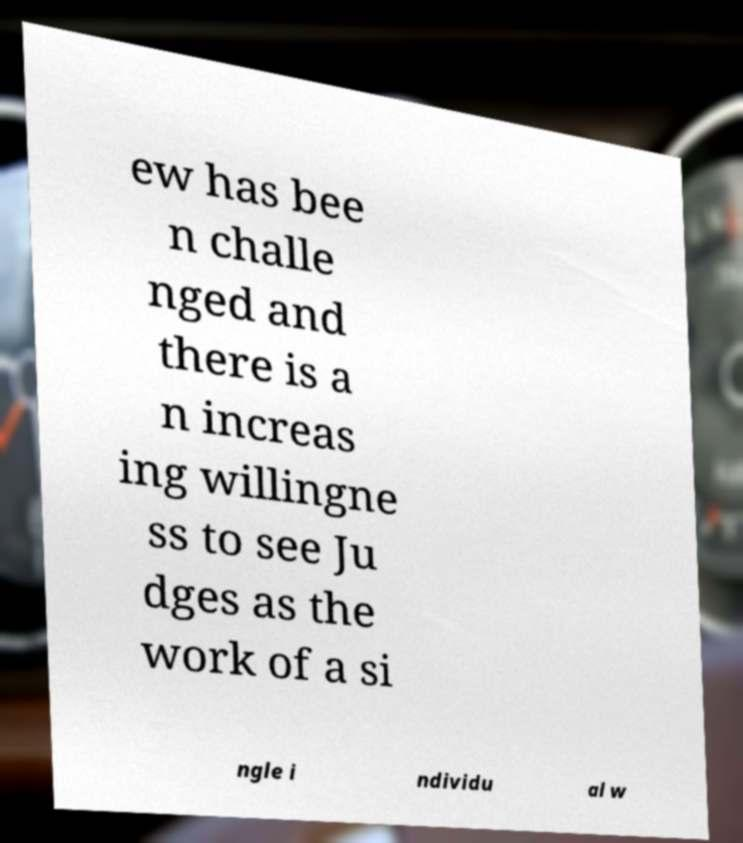Could you assist in decoding the text presented in this image and type it out clearly? ew has bee n challe nged and there is a n increas ing willingne ss to see Ju dges as the work of a si ngle i ndividu al w 